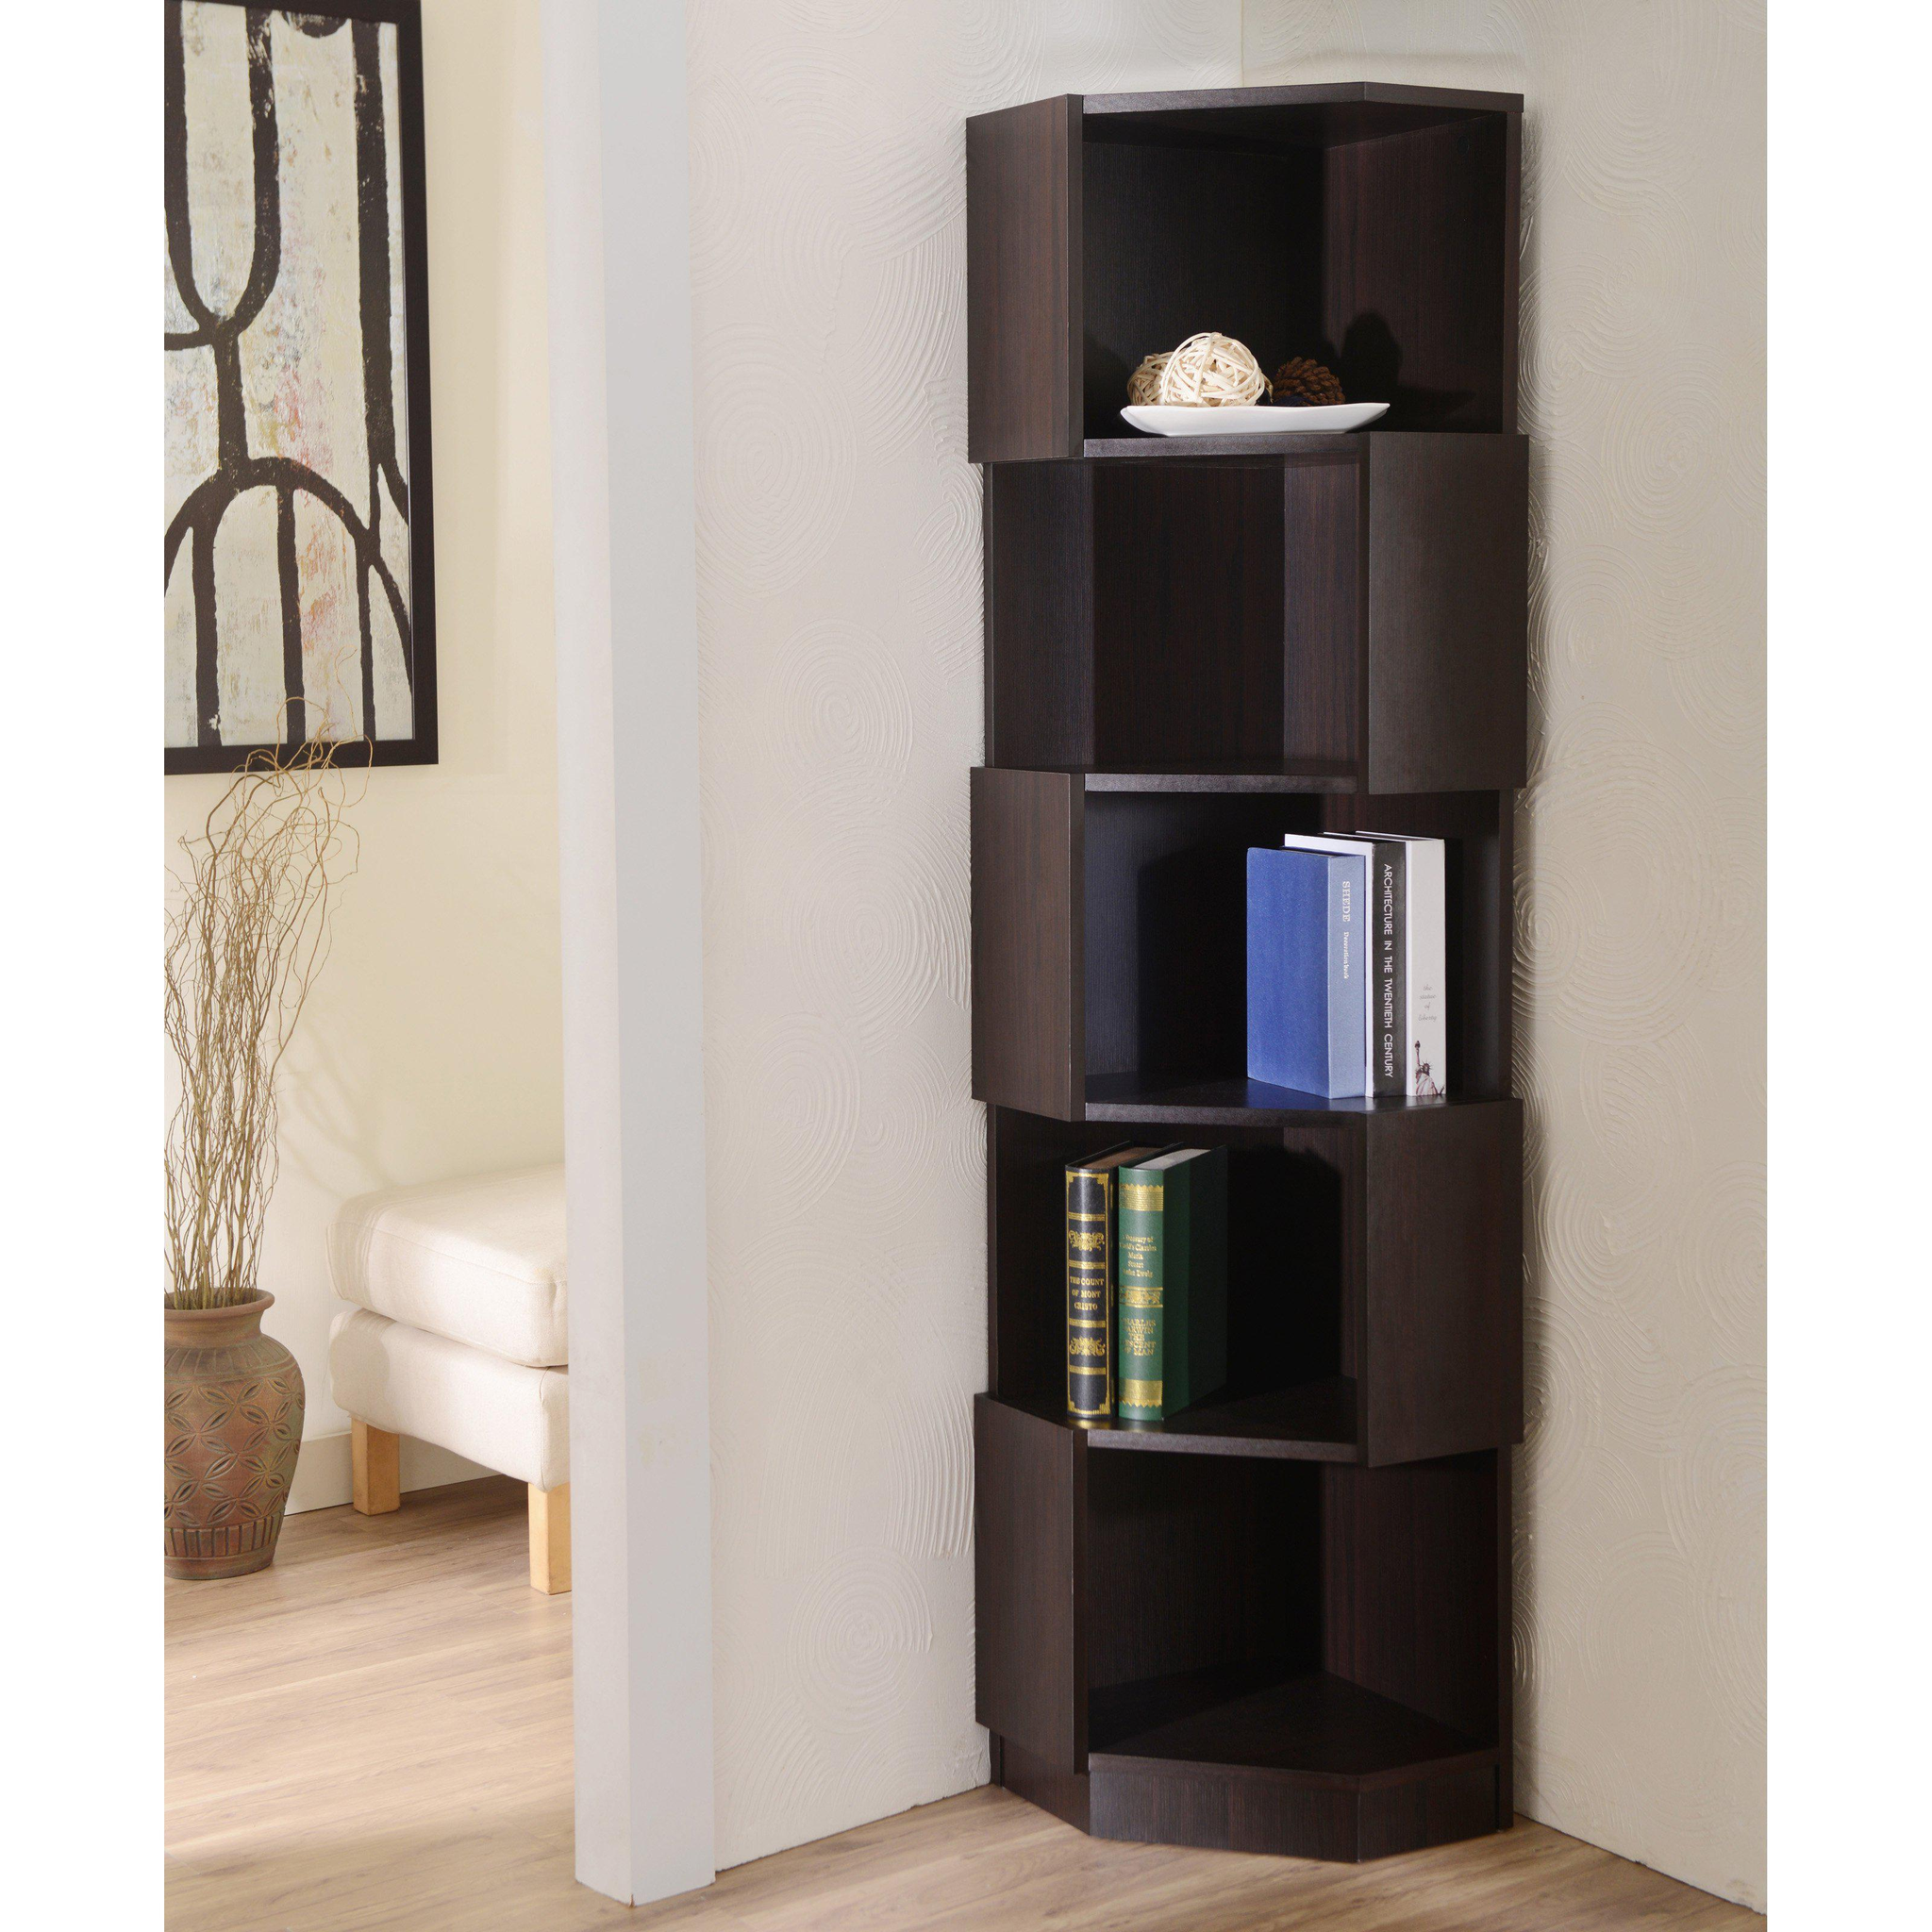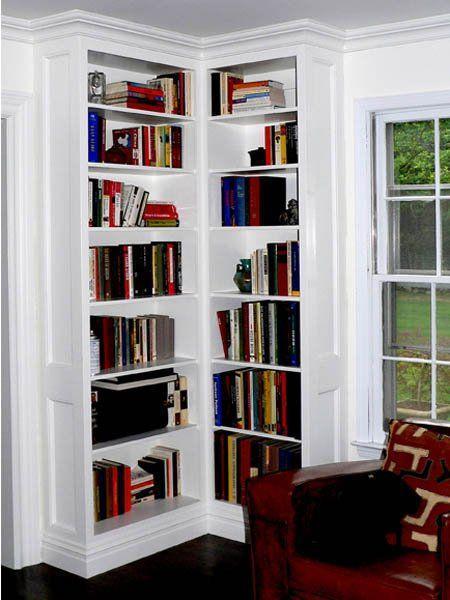The first image is the image on the left, the second image is the image on the right. Analyze the images presented: Is the assertion "An image features a black upright corner shelf unit with items displayed on some of the shelves." valid? Answer yes or no. Yes. 